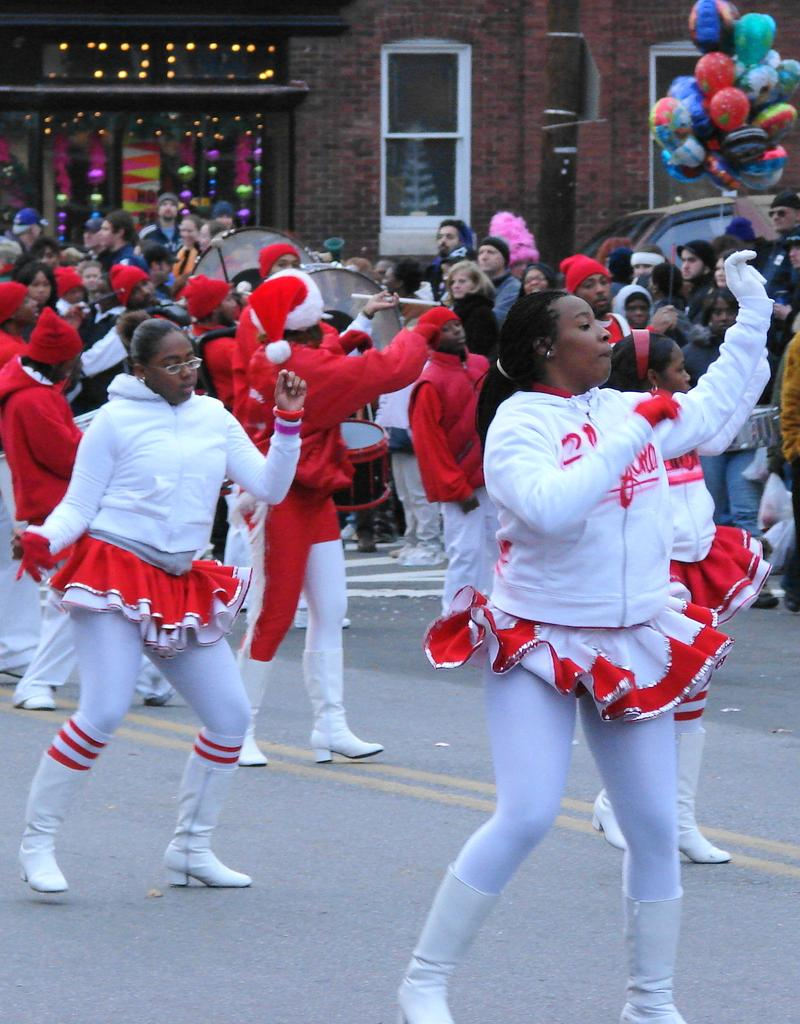How many people are in the image? There is a group of people in the image. Where are the people located in the image? The people are standing on the road. What are some people wearing in the image? Some people are wearing caps. What can be seen in the background of the image? There is a building, balloons, and a vehicle in the background of the image. What type of music can be heard coming from the vein in the image? There is no vein present in the image, and therefore no music can be heard coming from it. 